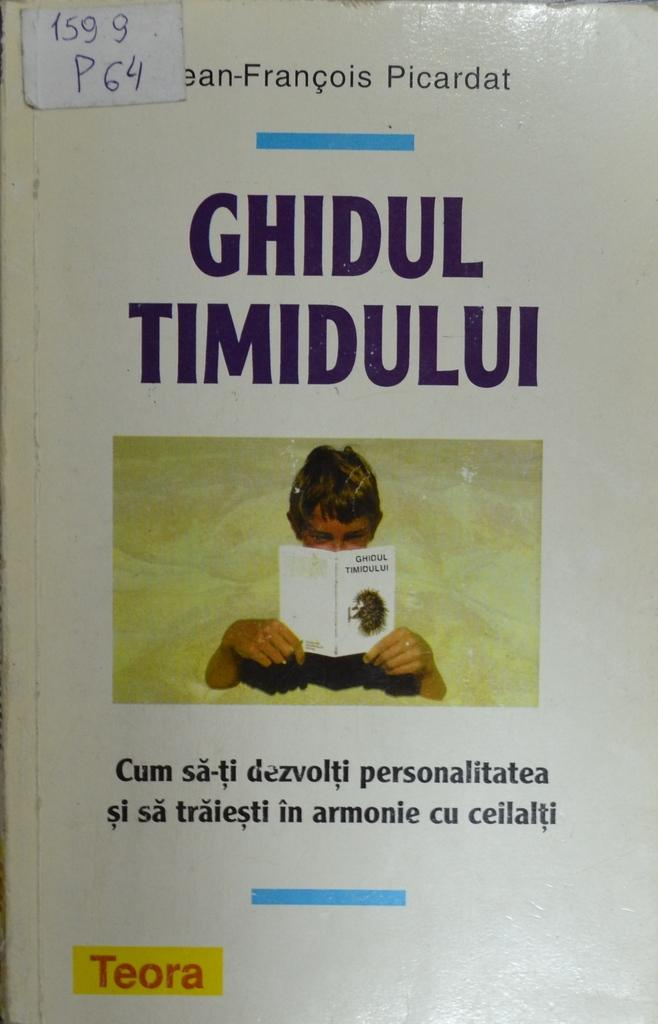<image>
Write a terse but informative summary of the picture. A book cover reads, "Ghidul Timidului" and has Teora in a yellow box. 